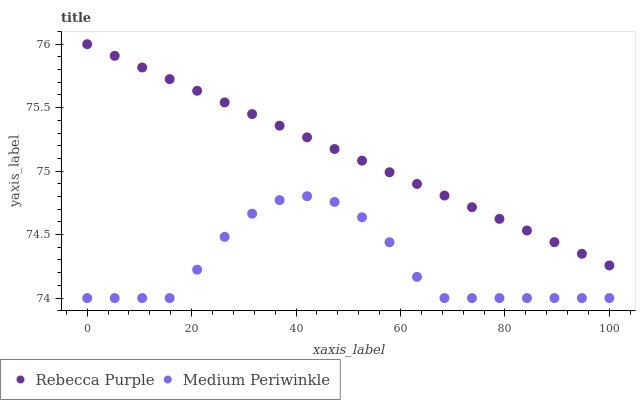Does Medium Periwinkle have the minimum area under the curve?
Answer yes or no. Yes. Does Rebecca Purple have the maximum area under the curve?
Answer yes or no. Yes. Does Rebecca Purple have the minimum area under the curve?
Answer yes or no. No. Is Rebecca Purple the smoothest?
Answer yes or no. Yes. Is Medium Periwinkle the roughest?
Answer yes or no. Yes. Is Rebecca Purple the roughest?
Answer yes or no. No. Does Medium Periwinkle have the lowest value?
Answer yes or no. Yes. Does Rebecca Purple have the lowest value?
Answer yes or no. No. Does Rebecca Purple have the highest value?
Answer yes or no. Yes. Is Medium Periwinkle less than Rebecca Purple?
Answer yes or no. Yes. Is Rebecca Purple greater than Medium Periwinkle?
Answer yes or no. Yes. Does Medium Periwinkle intersect Rebecca Purple?
Answer yes or no. No. 